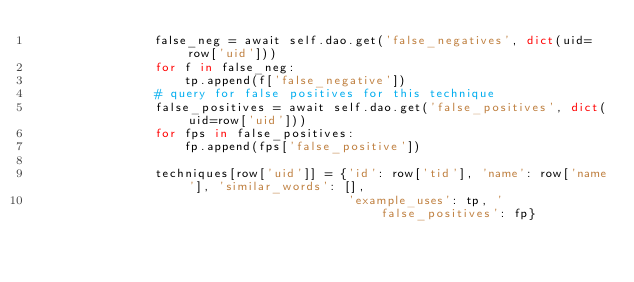Convert code to text. <code><loc_0><loc_0><loc_500><loc_500><_Python_>                false_neg = await self.dao.get('false_negatives', dict(uid=row['uid']))
                for f in false_neg:
                    tp.append(f['false_negative'])
                # query for false positives for this technique
                false_positives = await self.dao.get('false_positives', dict(uid=row['uid']))
                for fps in false_positives:
                    fp.append(fps['false_positive'])

                techniques[row['uid']] = {'id': row['tid'], 'name': row['name'], 'similar_words': [],
                                          'example_uses': tp, 'false_positives': fp}
</code> 